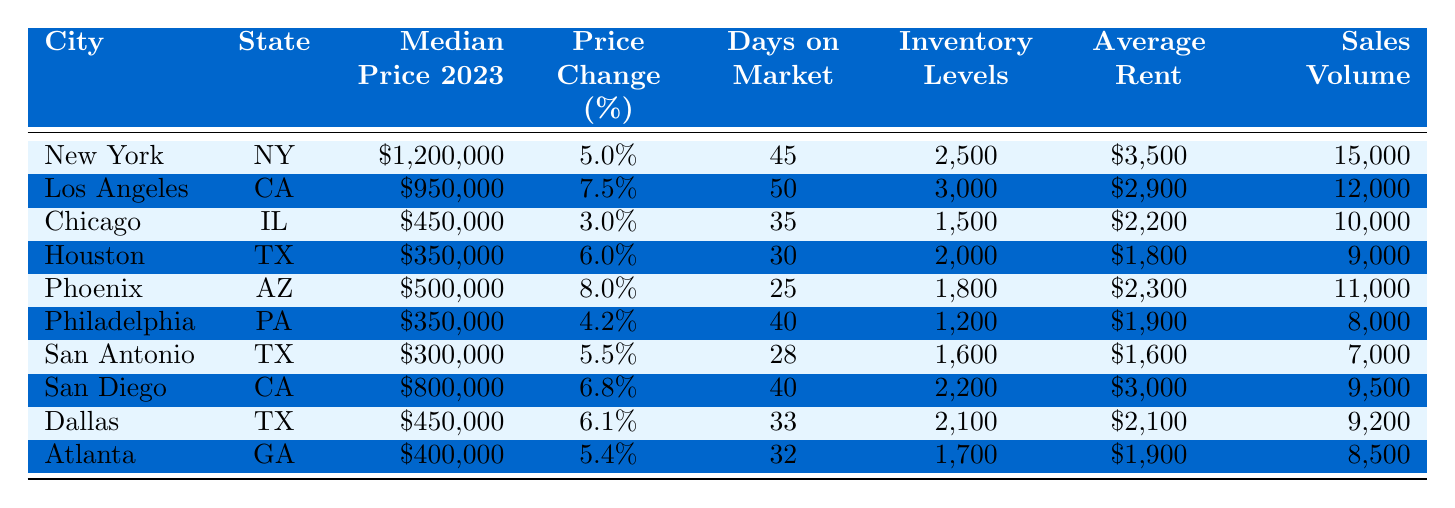What is the median price of residential real estate in New York for 2023? In the table, the row for New York lists the median price for 2023 as $1,200,000.
Answer: $1,200,000 Which city has the highest price change percentage in 2023? Looking at the "Price Change (%)" column, Phoenix has the highest percentage at 8.0%.
Answer: Phoenix How many days on average do homes remain on the market in Chicago? The "Days on Market" column shows that Chicago has an average of 35 days for homes on the market.
Answer: 35 What is the total sales volume of residential real estate in Los Angeles and San Diego combined? The sales volume for Los Angeles is 12,000 and for San Diego is 9,500. Adding them together gives 12,000 + 9,500 = 21,500.
Answer: 21,500 Is the average rent in San Antonio higher than in Philadelphia? The average rent in San Antonio is $1,600 and in Philadelphia is $1,900. Since $1,600 is less than $1,900, the answer is no.
Answer: No Which city has the lowest inventory levels? Referring to the "Inventory Levels" column, Philadelphia has the lowest at 1,200.
Answer: Philadelphia What is the difference in median price between Dallas and Houston? The median price for Dallas is $450,000 and for Houston is $350,000. The difference is $450,000 - $350,000 = $100,000.
Answer: $100,000 If we consider the average rent across all listed cities, which city has the rent closest to that average? First, sum the average rents: $3,500 + $2,900 + $2,200 + $1,800 + $2,300 + $1,900 + $1,600 + $3,000 + $2,100 + $1,900 = $23,300. Dividing by 10 gives an average rent of $2,330. The closest is Phoenix at $2,300.
Answer: Phoenix What percentage of the overall inventory levels do the homes in New York represent? The total inventory levels are 25,000 (2,500 + 3,000 + 1,500 + 2,000 + 1,800 + 1,200 + 1,600 + 2,200 + 2,100 + 1,700 = 25,000). New York’s inventory is 2,500, so the percentage is (2,500 / 25,000) * 100 = 10%.
Answer: 10% Which city has the lowest average rent, and what is the value? Comparing the average rents, San Antonio has the lowest at $1,600.
Answer: San Antonio, $1,600 